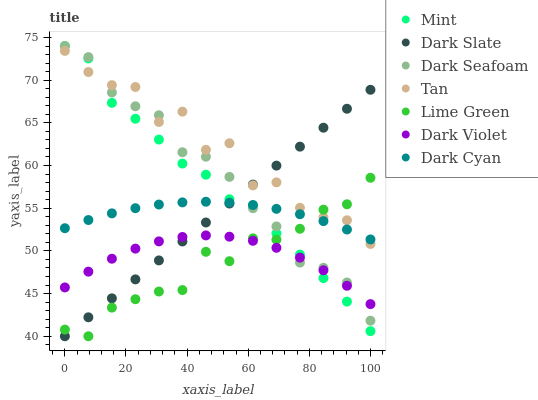Does Lime Green have the minimum area under the curve?
Answer yes or no. Yes. Does Tan have the maximum area under the curve?
Answer yes or no. Yes. Does Dark Violet have the minimum area under the curve?
Answer yes or no. No. Does Dark Violet have the maximum area under the curve?
Answer yes or no. No. Is Dark Slate the smoothest?
Answer yes or no. Yes. Is Tan the roughest?
Answer yes or no. Yes. Is Dark Violet the smoothest?
Answer yes or no. No. Is Dark Violet the roughest?
Answer yes or no. No. Does Lime Green have the lowest value?
Answer yes or no. Yes. Does Dark Violet have the lowest value?
Answer yes or no. No. Does Mint have the highest value?
Answer yes or no. Yes. Does Dark Slate have the highest value?
Answer yes or no. No. Is Dark Violet less than Tan?
Answer yes or no. Yes. Is Tan greater than Dark Violet?
Answer yes or no. Yes. Does Dark Slate intersect Dark Violet?
Answer yes or no. Yes. Is Dark Slate less than Dark Violet?
Answer yes or no. No. Is Dark Slate greater than Dark Violet?
Answer yes or no. No. Does Dark Violet intersect Tan?
Answer yes or no. No. 